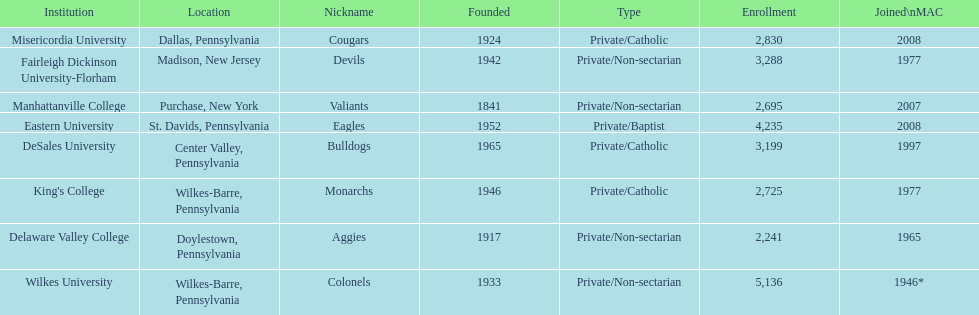What is the enrollment number of misericordia university? 2,830. 